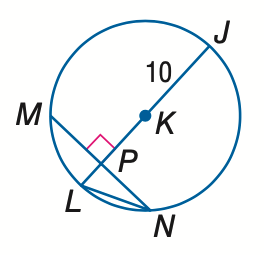Answer the mathemtical geometry problem and directly provide the correct option letter.
Question: In \odot K, M N = 16 and m \widehat M N = 98. Find the measure of L N. Round to the nearest hundredth.
Choices: A: 6.93 B: 7.50 C: 8.94 D: 10.00 C 